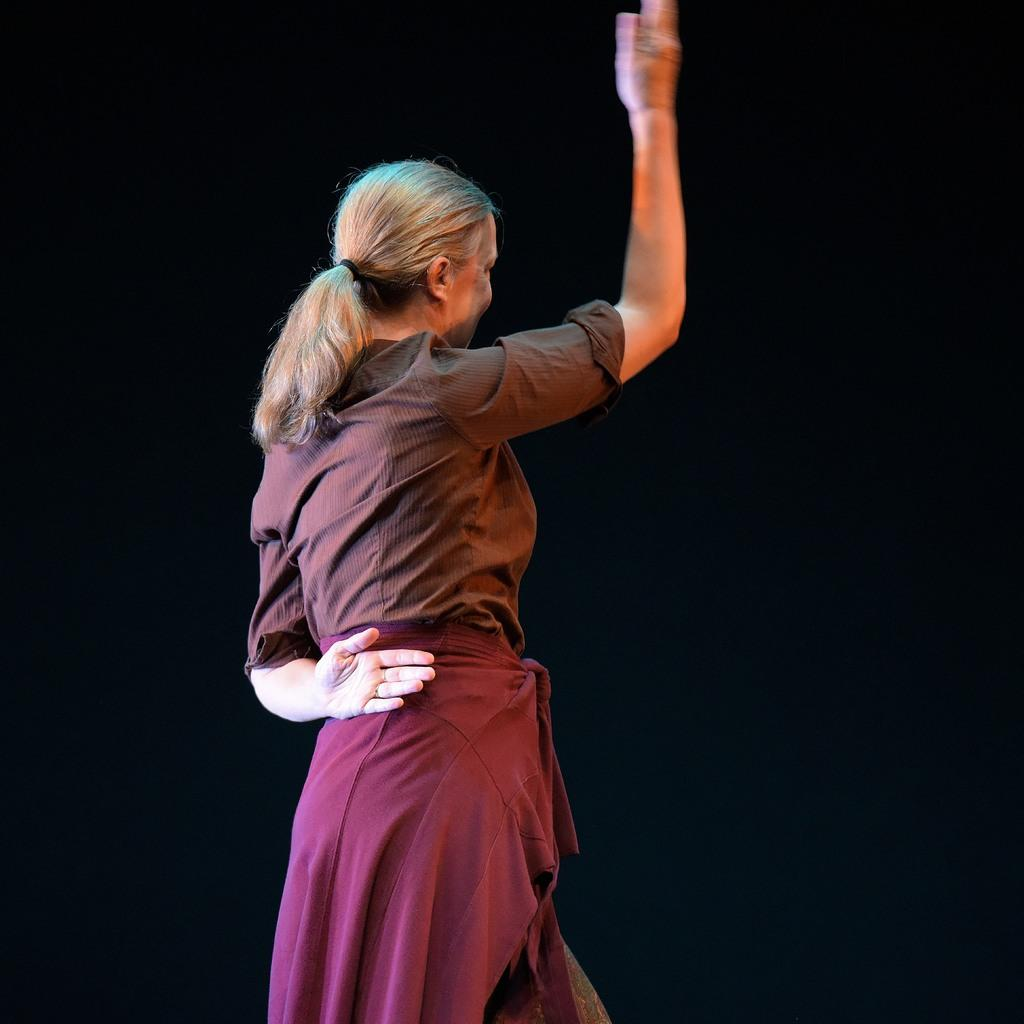Who is the main subject in the image? There is a woman in the image. What can be seen behind the woman? The background of the image is black. What type of birds are having a discussion in the image? There are no birds present in the image, and therefore no discussion involving birds can be observed. 